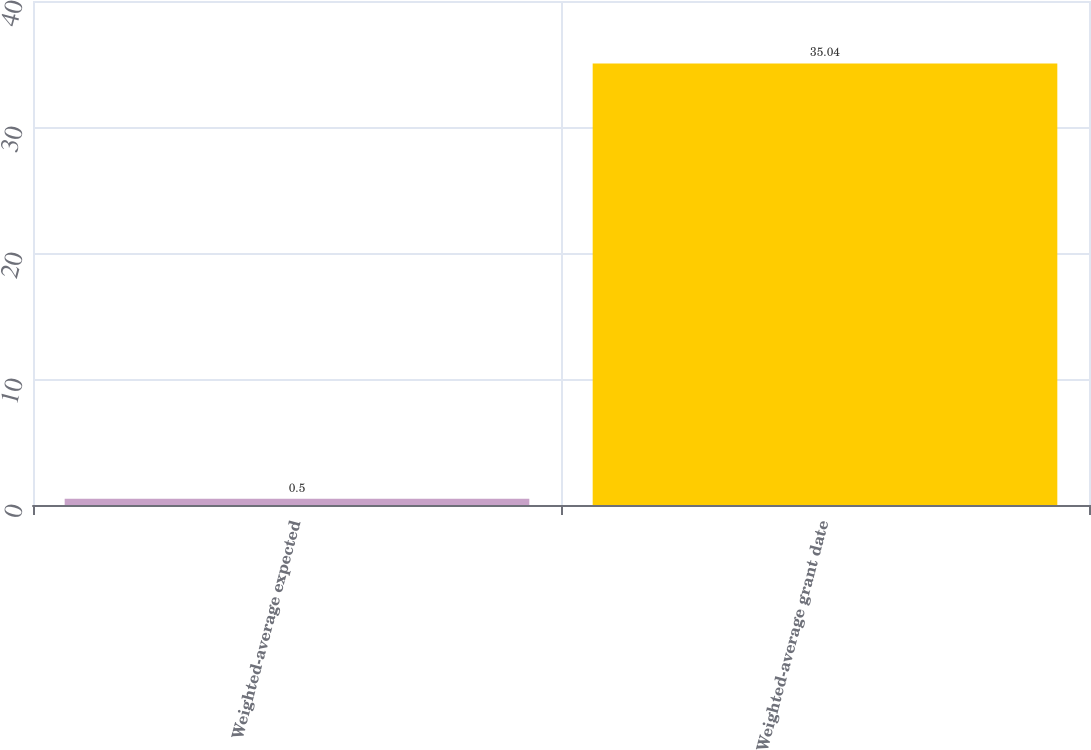Convert chart. <chart><loc_0><loc_0><loc_500><loc_500><bar_chart><fcel>Weighted-average expected<fcel>Weighted-average grant date<nl><fcel>0.5<fcel>35.04<nl></chart> 